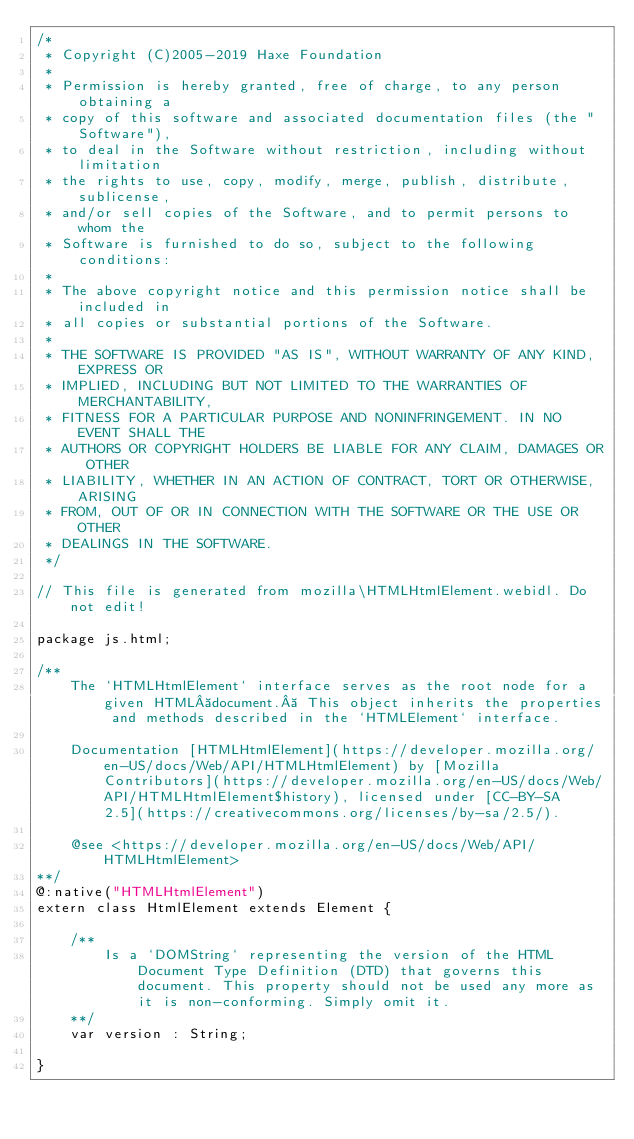<code> <loc_0><loc_0><loc_500><loc_500><_Haxe_>/*
 * Copyright (C)2005-2019 Haxe Foundation
 *
 * Permission is hereby granted, free of charge, to any person obtaining a
 * copy of this software and associated documentation files (the "Software"),
 * to deal in the Software without restriction, including without limitation
 * the rights to use, copy, modify, merge, publish, distribute, sublicense,
 * and/or sell copies of the Software, and to permit persons to whom the
 * Software is furnished to do so, subject to the following conditions:
 *
 * The above copyright notice and this permission notice shall be included in
 * all copies or substantial portions of the Software.
 *
 * THE SOFTWARE IS PROVIDED "AS IS", WITHOUT WARRANTY OF ANY KIND, EXPRESS OR
 * IMPLIED, INCLUDING BUT NOT LIMITED TO THE WARRANTIES OF MERCHANTABILITY,
 * FITNESS FOR A PARTICULAR PURPOSE AND NONINFRINGEMENT. IN NO EVENT SHALL THE
 * AUTHORS OR COPYRIGHT HOLDERS BE LIABLE FOR ANY CLAIM, DAMAGES OR OTHER
 * LIABILITY, WHETHER IN AN ACTION OF CONTRACT, TORT OR OTHERWISE, ARISING
 * FROM, OUT OF OR IN CONNECTION WITH THE SOFTWARE OR THE USE OR OTHER
 * DEALINGS IN THE SOFTWARE.
 */

// This file is generated from mozilla\HTMLHtmlElement.webidl. Do not edit!

package js.html;

/**
	The `HTMLHtmlElement` interface serves as the root node for a given HTML document.  This object inherits the properties and methods described in the `HTMLElement` interface.

	Documentation [HTMLHtmlElement](https://developer.mozilla.org/en-US/docs/Web/API/HTMLHtmlElement) by [Mozilla Contributors](https://developer.mozilla.org/en-US/docs/Web/API/HTMLHtmlElement$history), licensed under [CC-BY-SA 2.5](https://creativecommons.org/licenses/by-sa/2.5/).

	@see <https://developer.mozilla.org/en-US/docs/Web/API/HTMLHtmlElement>
**/
@:native("HTMLHtmlElement")
extern class HtmlElement extends Element {
	
	/**
		Is a `DOMString` representing the version of the HTML Document Type Definition (DTD) that governs this document. This property should not be used any more as it is non-conforming. Simply omit it.
	**/
	var version : String;
	
}</code> 